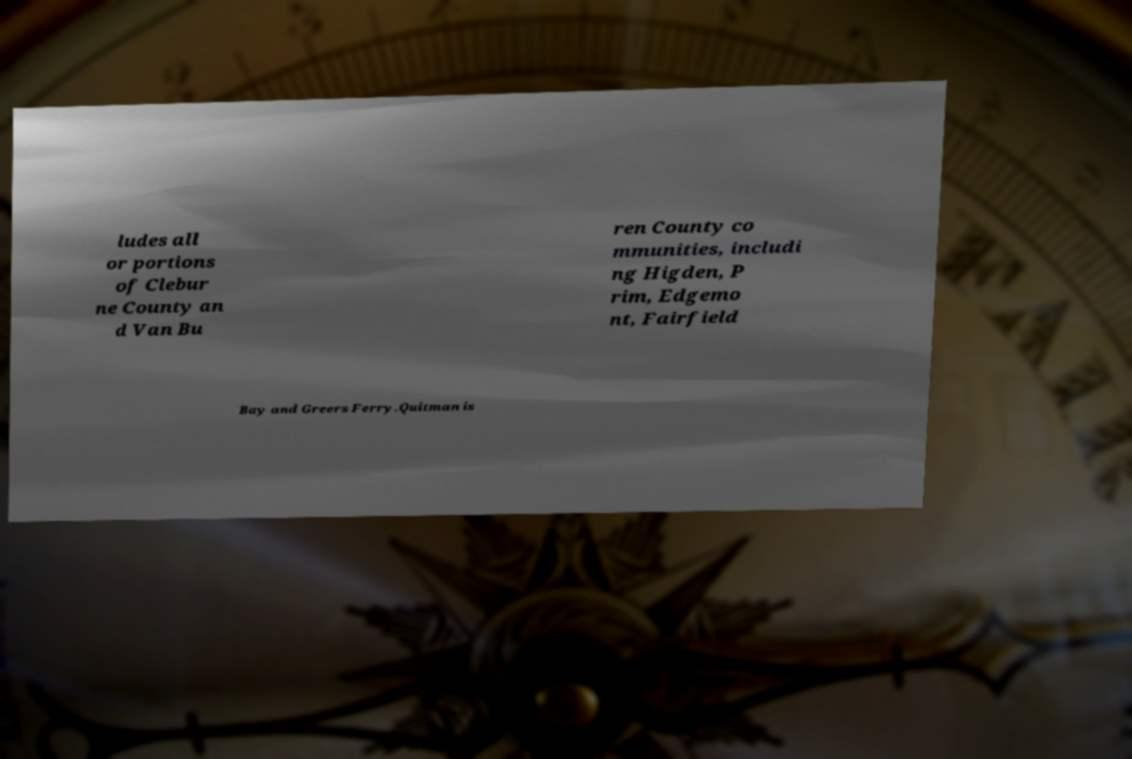Could you extract and type out the text from this image? ludes all or portions of Clebur ne County an d Van Bu ren County co mmunities, includi ng Higden, P rim, Edgemo nt, Fairfield Bay and Greers Ferry.Quitman is 